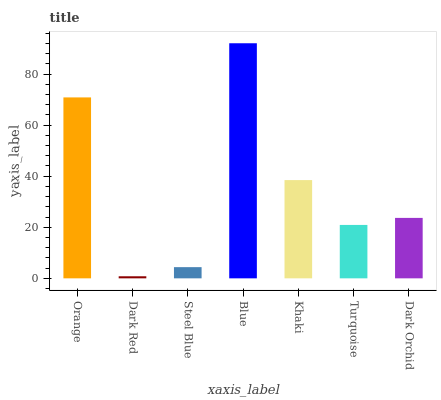Is Dark Red the minimum?
Answer yes or no. Yes. Is Blue the maximum?
Answer yes or no. Yes. Is Steel Blue the minimum?
Answer yes or no. No. Is Steel Blue the maximum?
Answer yes or no. No. Is Steel Blue greater than Dark Red?
Answer yes or no. Yes. Is Dark Red less than Steel Blue?
Answer yes or no. Yes. Is Dark Red greater than Steel Blue?
Answer yes or no. No. Is Steel Blue less than Dark Red?
Answer yes or no. No. Is Dark Orchid the high median?
Answer yes or no. Yes. Is Dark Orchid the low median?
Answer yes or no. Yes. Is Blue the high median?
Answer yes or no. No. Is Dark Red the low median?
Answer yes or no. No. 